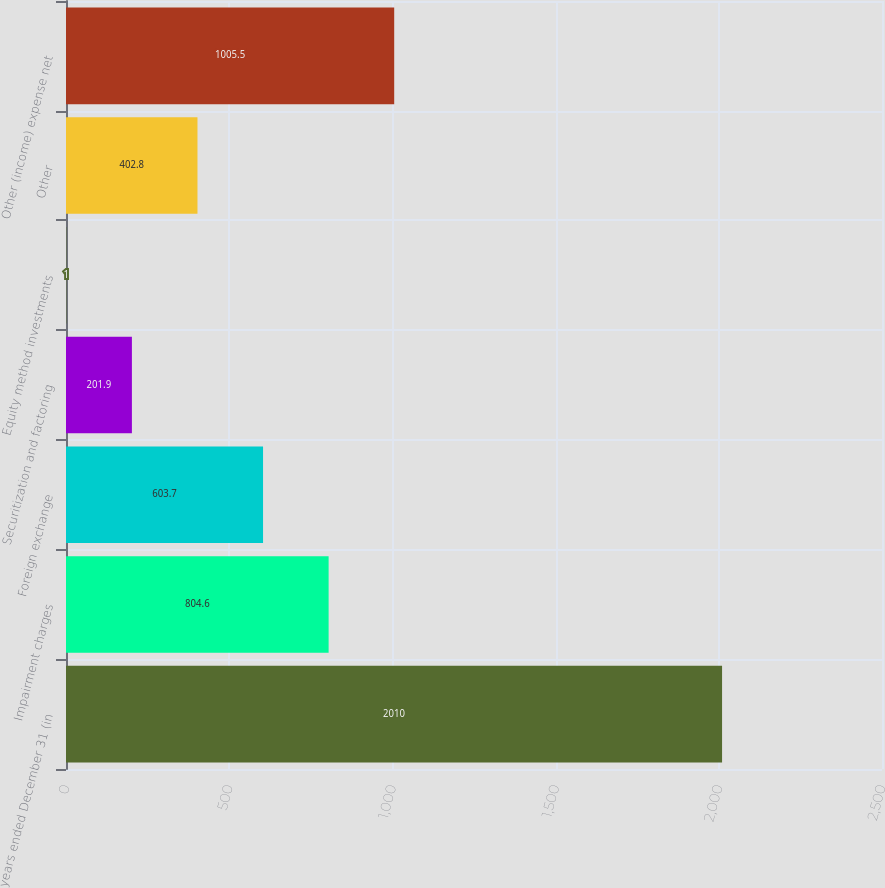<chart> <loc_0><loc_0><loc_500><loc_500><bar_chart><fcel>years ended December 31 (in<fcel>Impairment charges<fcel>Foreign exchange<fcel>Securitization and factoring<fcel>Equity method investments<fcel>Other<fcel>Other (income) expense net<nl><fcel>2010<fcel>804.6<fcel>603.7<fcel>201.9<fcel>1<fcel>402.8<fcel>1005.5<nl></chart> 